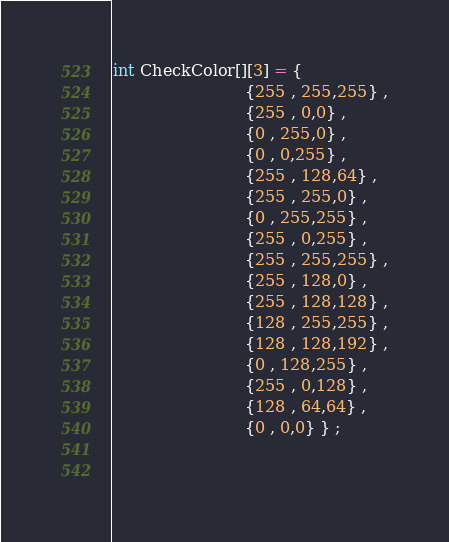<code> <loc_0><loc_0><loc_500><loc_500><_C_>
int CheckColor[][3] = {
                          {255 , 255,255} ,
                          {255 , 0,0} ,
                          {0 , 255,0} ,
                          {0 , 0,255} ,
                          {255 , 128,64} ,
                          {255 , 255,0} ,
                          {0 , 255,255} ,
                          {255 , 0,255} ,
                          {255 , 255,255} ,
                          {255 , 128,0} ,
                          {255 , 128,128} ,
                          {128 , 255,255} ,
                          {128 , 128,192} ,
                          {0 , 128,255} ,
                          {255 , 0,128} ,
                          {128 , 64,64} ,
                          {0 , 0,0} } ;
                     
                          
</code> 